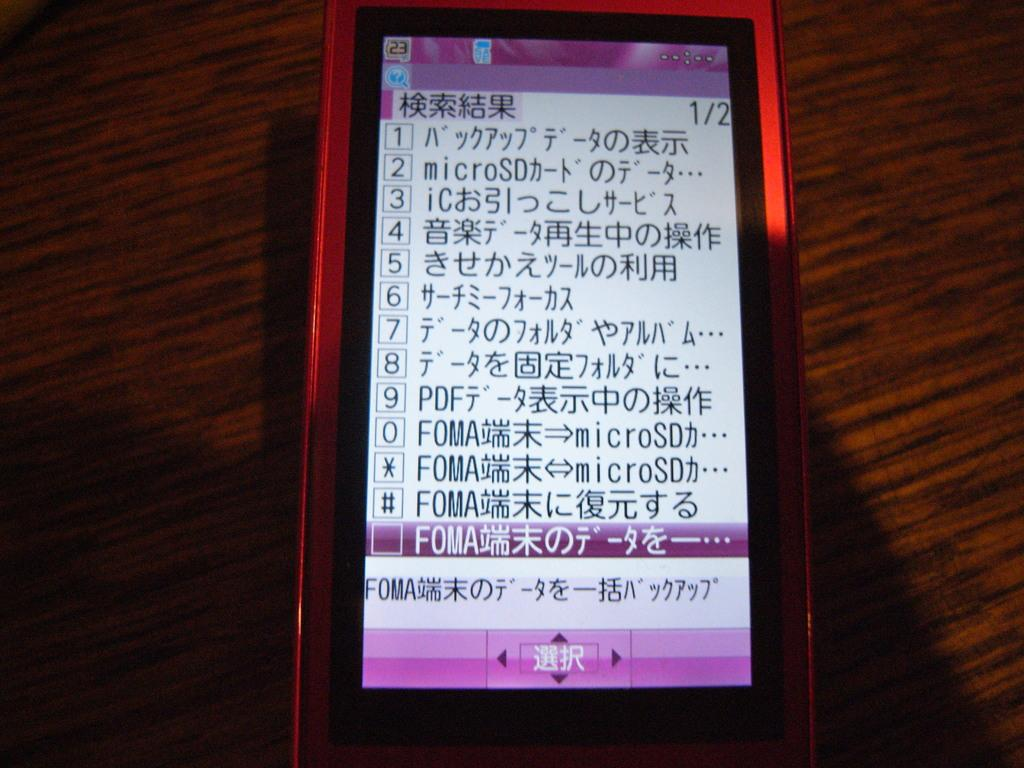<image>
Relay a brief, clear account of the picture shown. The phone shows a list in another language besides English.. 